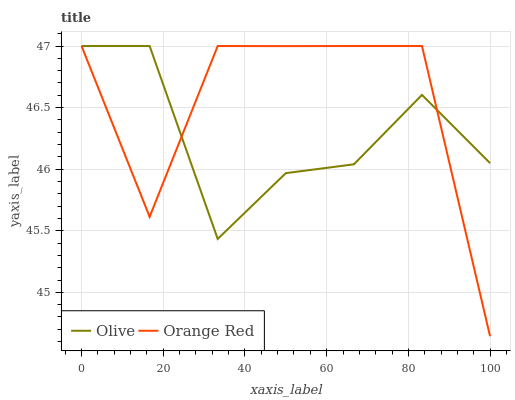Does Olive have the minimum area under the curve?
Answer yes or no. Yes. Does Orange Red have the maximum area under the curve?
Answer yes or no. Yes. Does Orange Red have the minimum area under the curve?
Answer yes or no. No. Is Olive the smoothest?
Answer yes or no. Yes. Is Orange Red the roughest?
Answer yes or no. Yes. Is Orange Red the smoothest?
Answer yes or no. No. Does Orange Red have the lowest value?
Answer yes or no. Yes. Does Orange Red have the highest value?
Answer yes or no. Yes. Does Orange Red intersect Olive?
Answer yes or no. Yes. Is Orange Red less than Olive?
Answer yes or no. No. Is Orange Red greater than Olive?
Answer yes or no. No. 